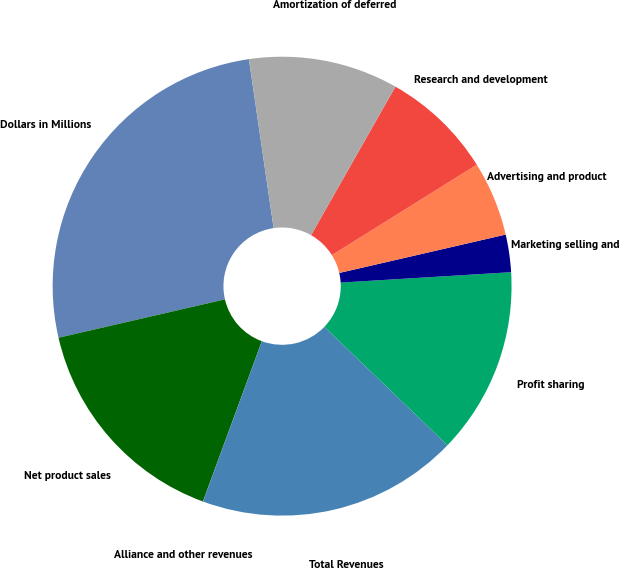Convert chart. <chart><loc_0><loc_0><loc_500><loc_500><pie_chart><fcel>Dollars in Millions<fcel>Net product sales<fcel>Alliance and other revenues<fcel>Total Revenues<fcel>Profit sharing<fcel>Marketing selling and<fcel>Advertising and product<fcel>Research and development<fcel>Amortization of deferred<nl><fcel>26.3%<fcel>15.78%<fcel>0.01%<fcel>18.41%<fcel>13.16%<fcel>2.64%<fcel>5.27%<fcel>7.9%<fcel>10.53%<nl></chart> 